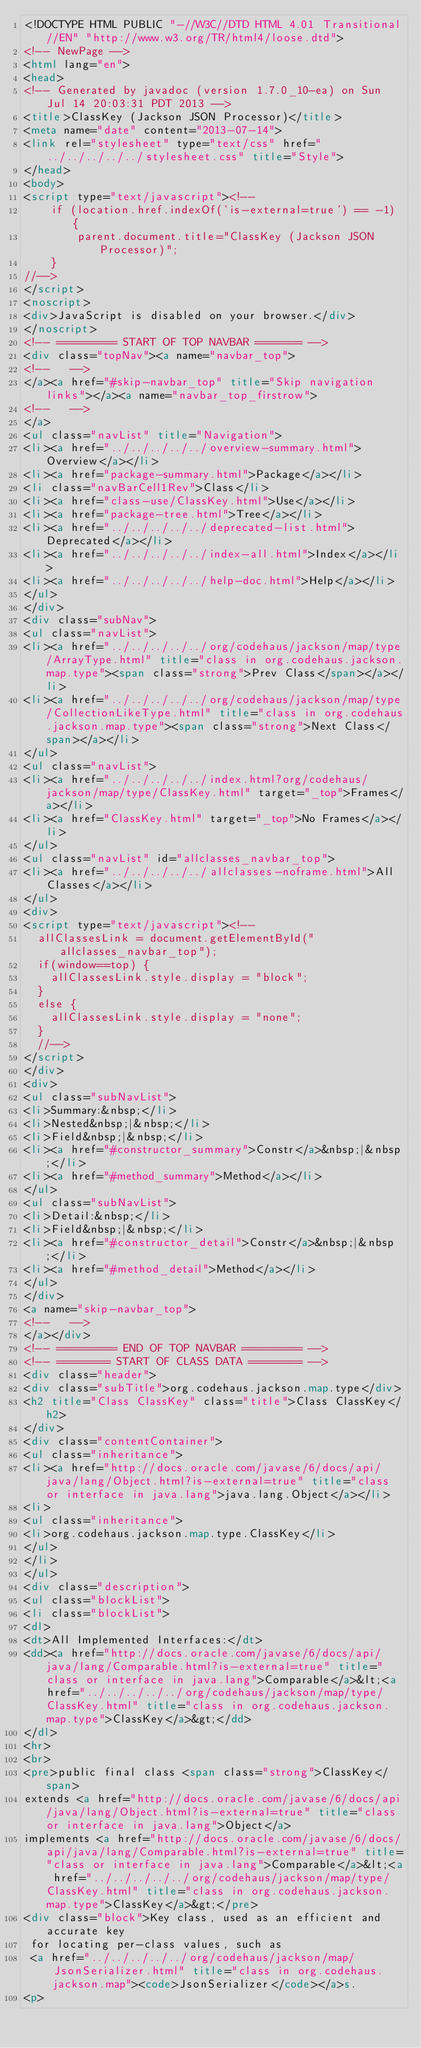Convert code to text. <code><loc_0><loc_0><loc_500><loc_500><_HTML_><!DOCTYPE HTML PUBLIC "-//W3C//DTD HTML 4.01 Transitional//EN" "http://www.w3.org/TR/html4/loose.dtd">
<!-- NewPage -->
<html lang="en">
<head>
<!-- Generated by javadoc (version 1.7.0_10-ea) on Sun Jul 14 20:03:31 PDT 2013 -->
<title>ClassKey (Jackson JSON Processor)</title>
<meta name="date" content="2013-07-14">
<link rel="stylesheet" type="text/css" href="../../../../../stylesheet.css" title="Style">
</head>
<body>
<script type="text/javascript"><!--
    if (location.href.indexOf('is-external=true') == -1) {
        parent.document.title="ClassKey (Jackson JSON Processor)";
    }
//-->
</script>
<noscript>
<div>JavaScript is disabled on your browser.</div>
</noscript>
<!-- ========= START OF TOP NAVBAR ======= -->
<div class="topNav"><a name="navbar_top">
<!--   -->
</a><a href="#skip-navbar_top" title="Skip navigation links"></a><a name="navbar_top_firstrow">
<!--   -->
</a>
<ul class="navList" title="Navigation">
<li><a href="../../../../../overview-summary.html">Overview</a></li>
<li><a href="package-summary.html">Package</a></li>
<li class="navBarCell1Rev">Class</li>
<li><a href="class-use/ClassKey.html">Use</a></li>
<li><a href="package-tree.html">Tree</a></li>
<li><a href="../../../../../deprecated-list.html">Deprecated</a></li>
<li><a href="../../../../../index-all.html">Index</a></li>
<li><a href="../../../../../help-doc.html">Help</a></li>
</ul>
</div>
<div class="subNav">
<ul class="navList">
<li><a href="../../../../../org/codehaus/jackson/map/type/ArrayType.html" title="class in org.codehaus.jackson.map.type"><span class="strong">Prev Class</span></a></li>
<li><a href="../../../../../org/codehaus/jackson/map/type/CollectionLikeType.html" title="class in org.codehaus.jackson.map.type"><span class="strong">Next Class</span></a></li>
</ul>
<ul class="navList">
<li><a href="../../../../../index.html?org/codehaus/jackson/map/type/ClassKey.html" target="_top">Frames</a></li>
<li><a href="ClassKey.html" target="_top">No Frames</a></li>
</ul>
<ul class="navList" id="allclasses_navbar_top">
<li><a href="../../../../../allclasses-noframe.html">All Classes</a></li>
</ul>
<div>
<script type="text/javascript"><!--
  allClassesLink = document.getElementById("allclasses_navbar_top");
  if(window==top) {
    allClassesLink.style.display = "block";
  }
  else {
    allClassesLink.style.display = "none";
  }
  //-->
</script>
</div>
<div>
<ul class="subNavList">
<li>Summary:&nbsp;</li>
<li>Nested&nbsp;|&nbsp;</li>
<li>Field&nbsp;|&nbsp;</li>
<li><a href="#constructor_summary">Constr</a>&nbsp;|&nbsp;</li>
<li><a href="#method_summary">Method</a></li>
</ul>
<ul class="subNavList">
<li>Detail:&nbsp;</li>
<li>Field&nbsp;|&nbsp;</li>
<li><a href="#constructor_detail">Constr</a>&nbsp;|&nbsp;</li>
<li><a href="#method_detail">Method</a></li>
</ul>
</div>
<a name="skip-navbar_top">
<!--   -->
</a></div>
<!-- ========= END OF TOP NAVBAR ========= -->
<!-- ======== START OF CLASS DATA ======== -->
<div class="header">
<div class="subTitle">org.codehaus.jackson.map.type</div>
<h2 title="Class ClassKey" class="title">Class ClassKey</h2>
</div>
<div class="contentContainer">
<ul class="inheritance">
<li><a href="http://docs.oracle.com/javase/6/docs/api/java/lang/Object.html?is-external=true" title="class or interface in java.lang">java.lang.Object</a></li>
<li>
<ul class="inheritance">
<li>org.codehaus.jackson.map.type.ClassKey</li>
</ul>
</li>
</ul>
<div class="description">
<ul class="blockList">
<li class="blockList">
<dl>
<dt>All Implemented Interfaces:</dt>
<dd><a href="http://docs.oracle.com/javase/6/docs/api/java/lang/Comparable.html?is-external=true" title="class or interface in java.lang">Comparable</a>&lt;<a href="../../../../../org/codehaus/jackson/map/type/ClassKey.html" title="class in org.codehaus.jackson.map.type">ClassKey</a>&gt;</dd>
</dl>
<hr>
<br>
<pre>public final class <span class="strong">ClassKey</span>
extends <a href="http://docs.oracle.com/javase/6/docs/api/java/lang/Object.html?is-external=true" title="class or interface in java.lang">Object</a>
implements <a href="http://docs.oracle.com/javase/6/docs/api/java/lang/Comparable.html?is-external=true" title="class or interface in java.lang">Comparable</a>&lt;<a href="../../../../../org/codehaus/jackson/map/type/ClassKey.html" title="class in org.codehaus.jackson.map.type">ClassKey</a>&gt;</pre>
<div class="block">Key class, used as an efficient and accurate key
 for locating per-class values, such as
 <a href="../../../../../org/codehaus/jackson/map/JsonSerializer.html" title="class in org.codehaus.jackson.map"><code>JsonSerializer</code></a>s.
<p></code> 